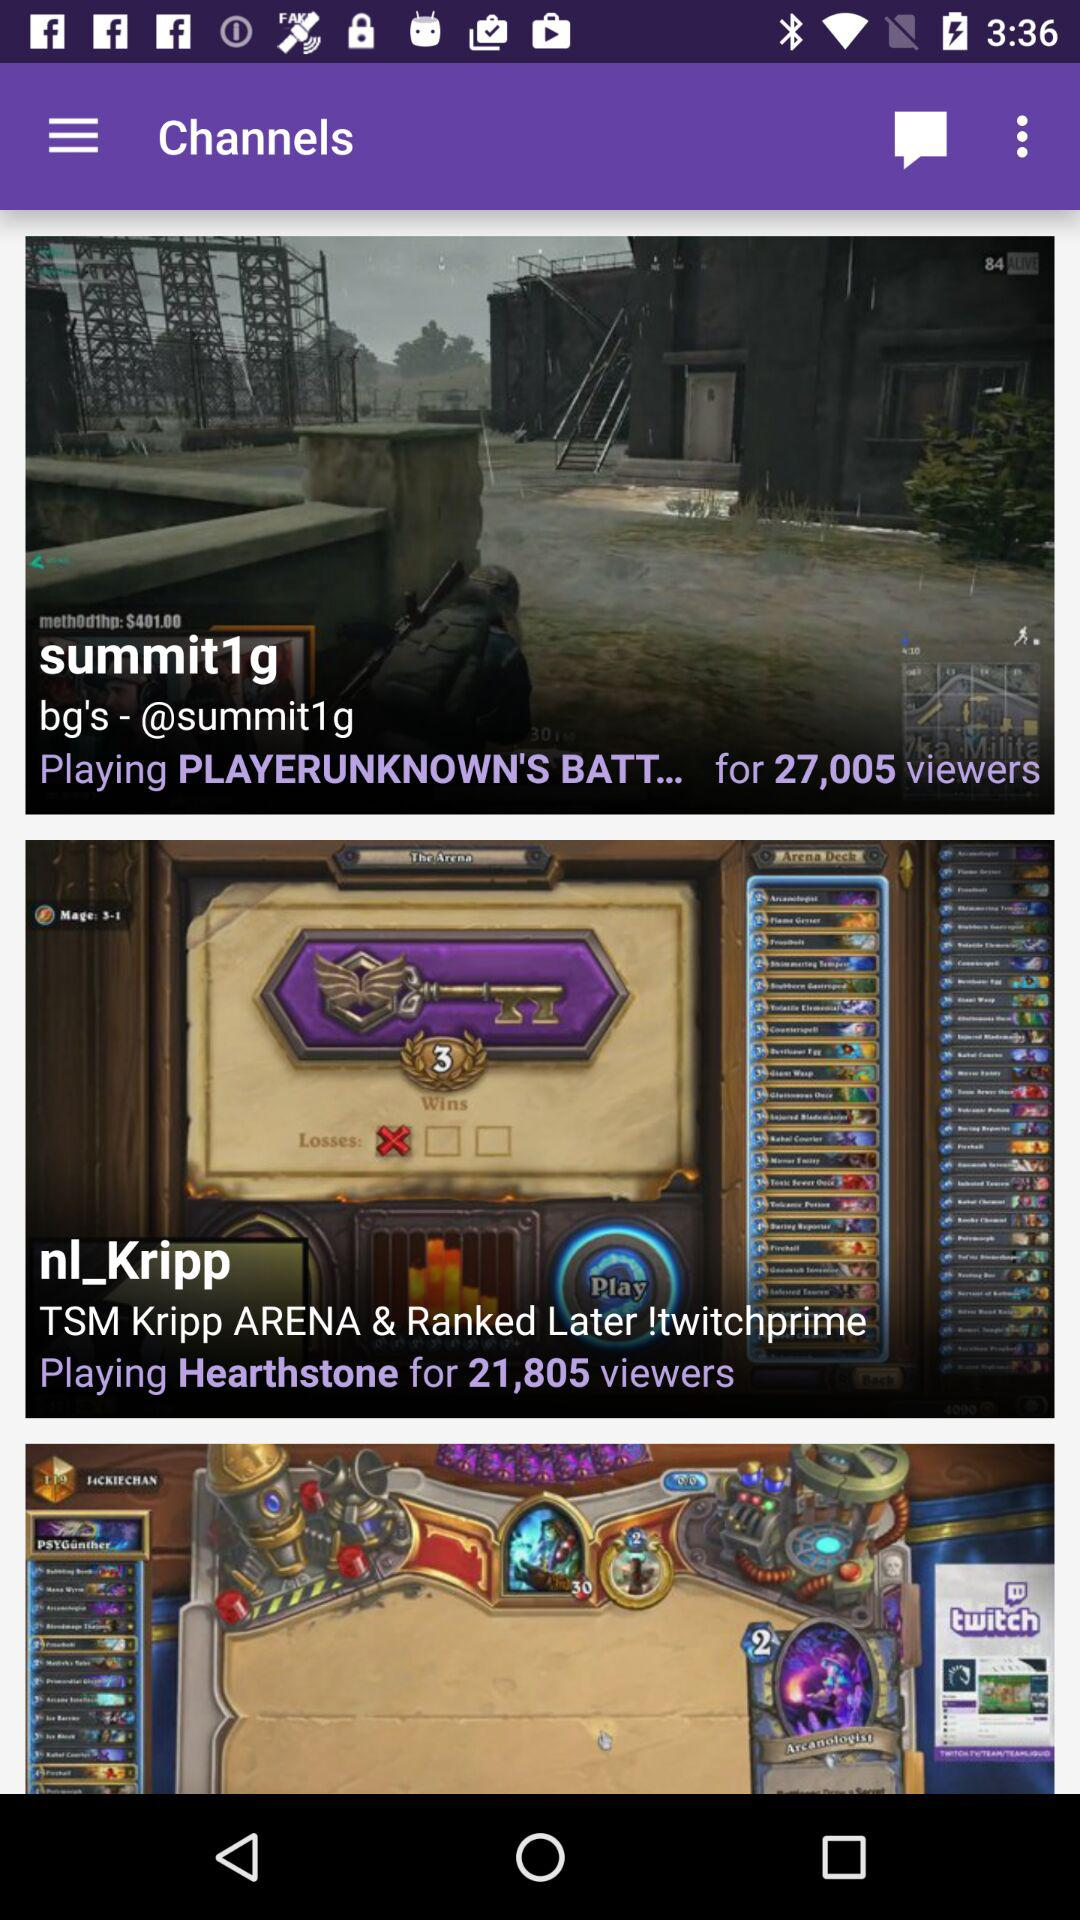How many viewers are there for the channel "summit1g"? There are 27,005 viewers. 